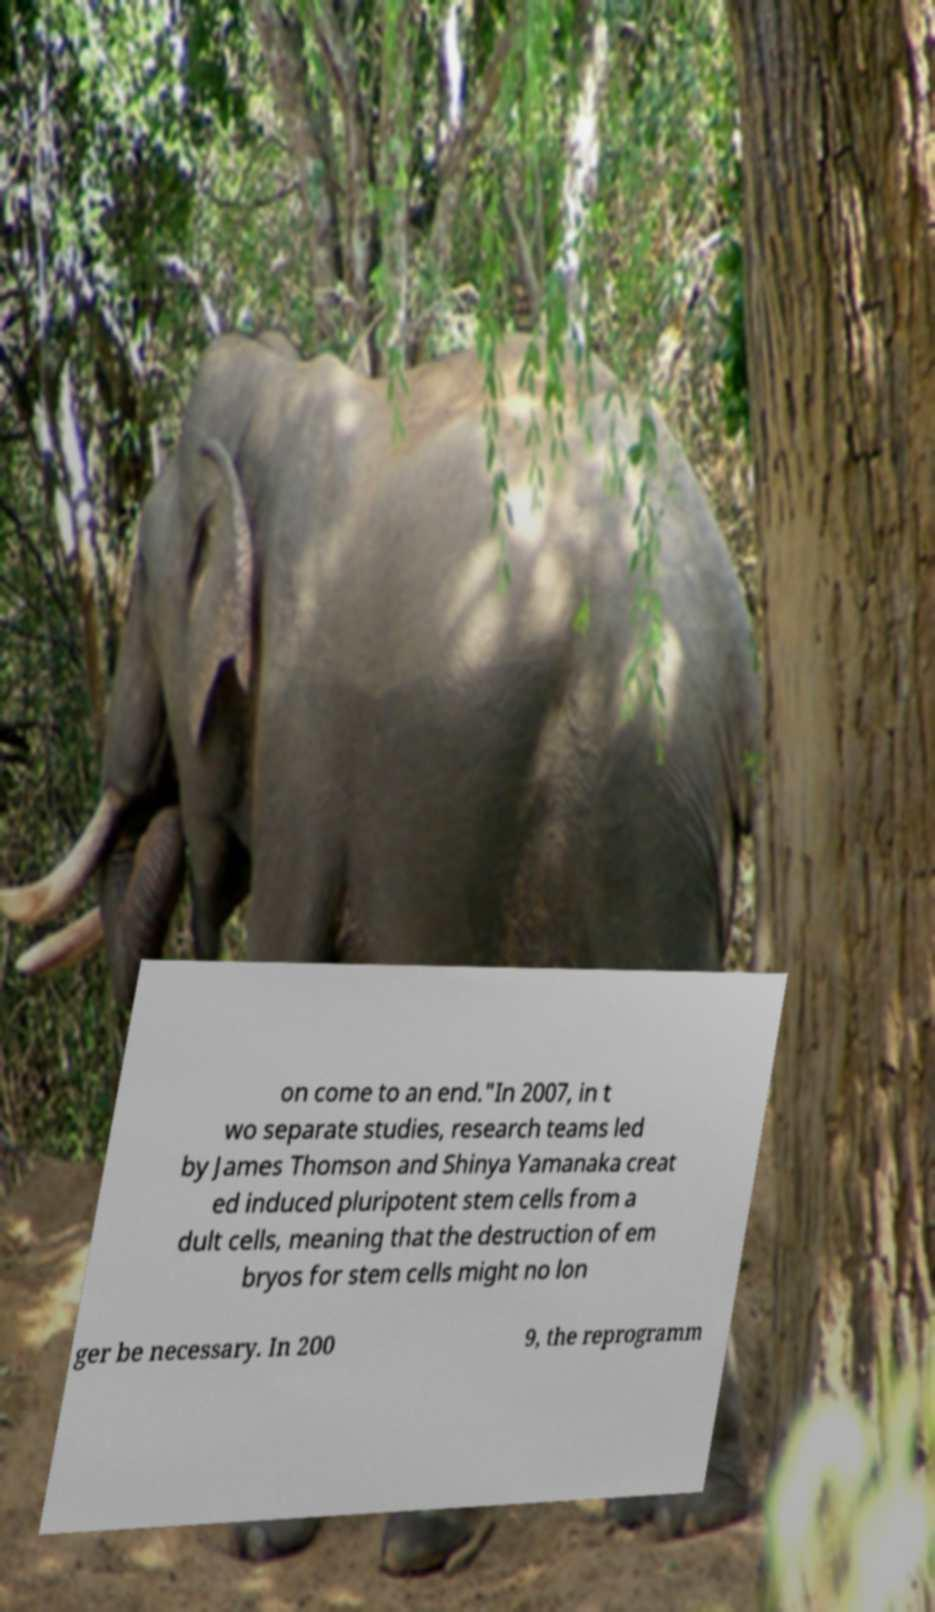There's text embedded in this image that I need extracted. Can you transcribe it verbatim? on come to an end."In 2007, in t wo separate studies, research teams led by James Thomson and Shinya Yamanaka creat ed induced pluripotent stem cells from a dult cells, meaning that the destruction of em bryos for stem cells might no lon ger be necessary. In 200 9, the reprogramm 